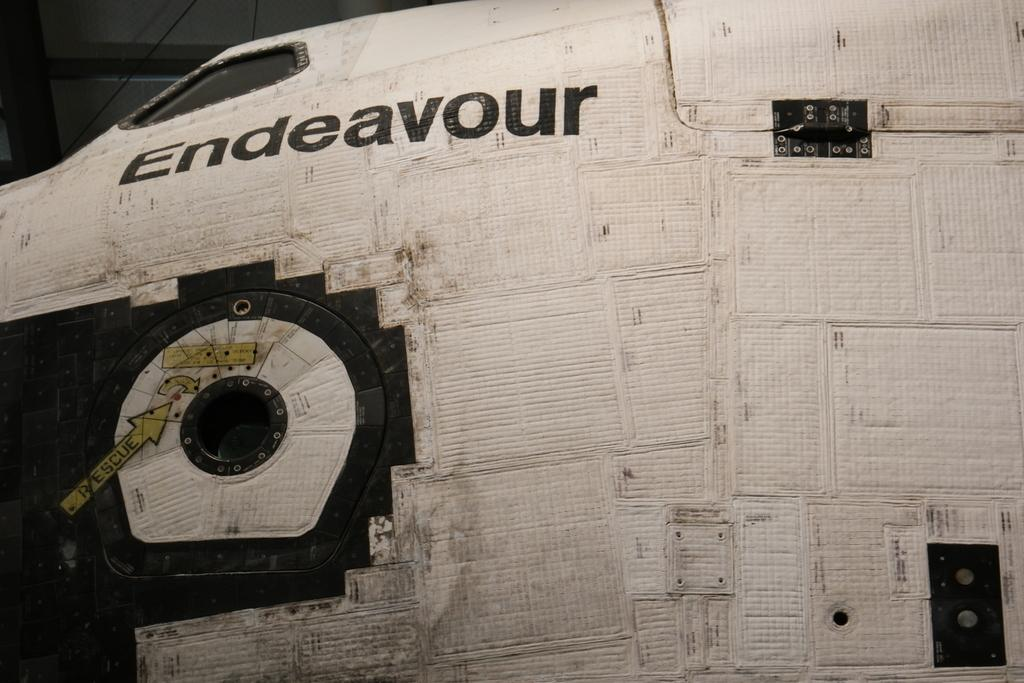<image>
Render a clear and concise summary of the photo. A plane fuselage on which the is written "..deavour" 